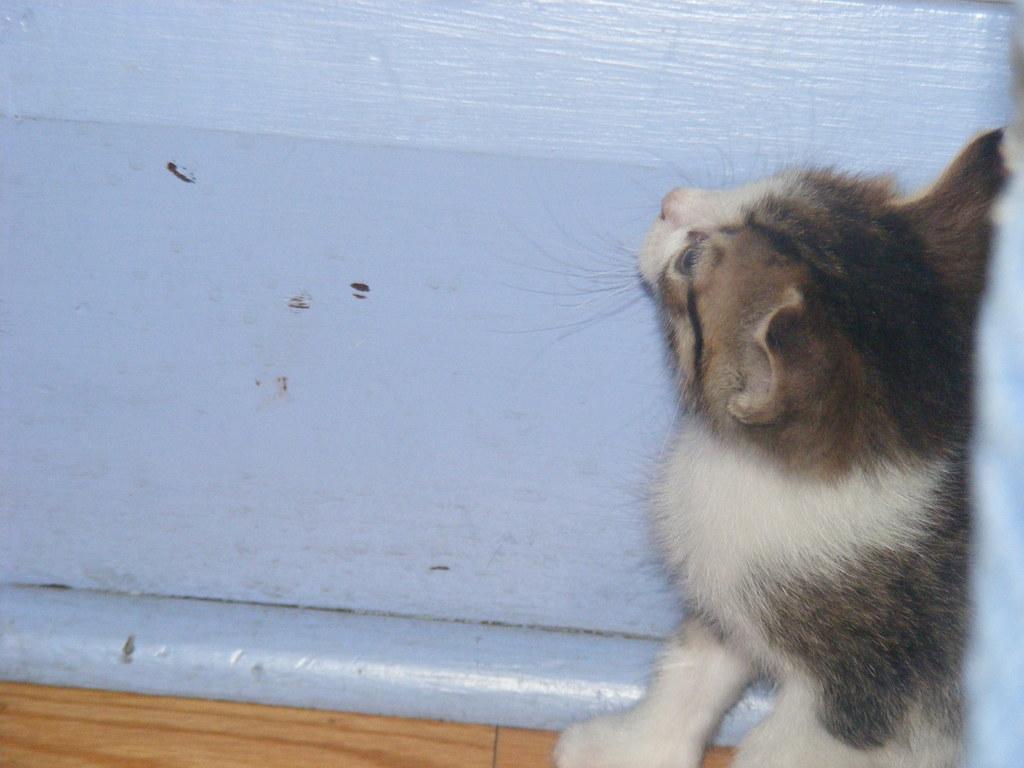Can you describe this image briefly? In this image we can see a cat. In the background there is a wall. 